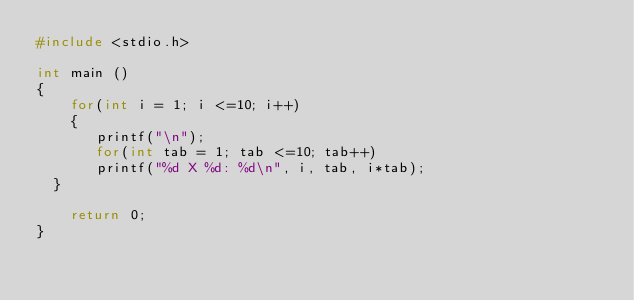<code> <loc_0><loc_0><loc_500><loc_500><_C++_>#include <stdio.h>

int main ()
{
    for(int i = 1; i <=10; i++)
    {
       printf("\n");
       for(int tab = 1; tab <=10; tab++)
       printf("%d X %d: %d\n", i, tab, i*tab);
	}

    return 0;
}
</code> 